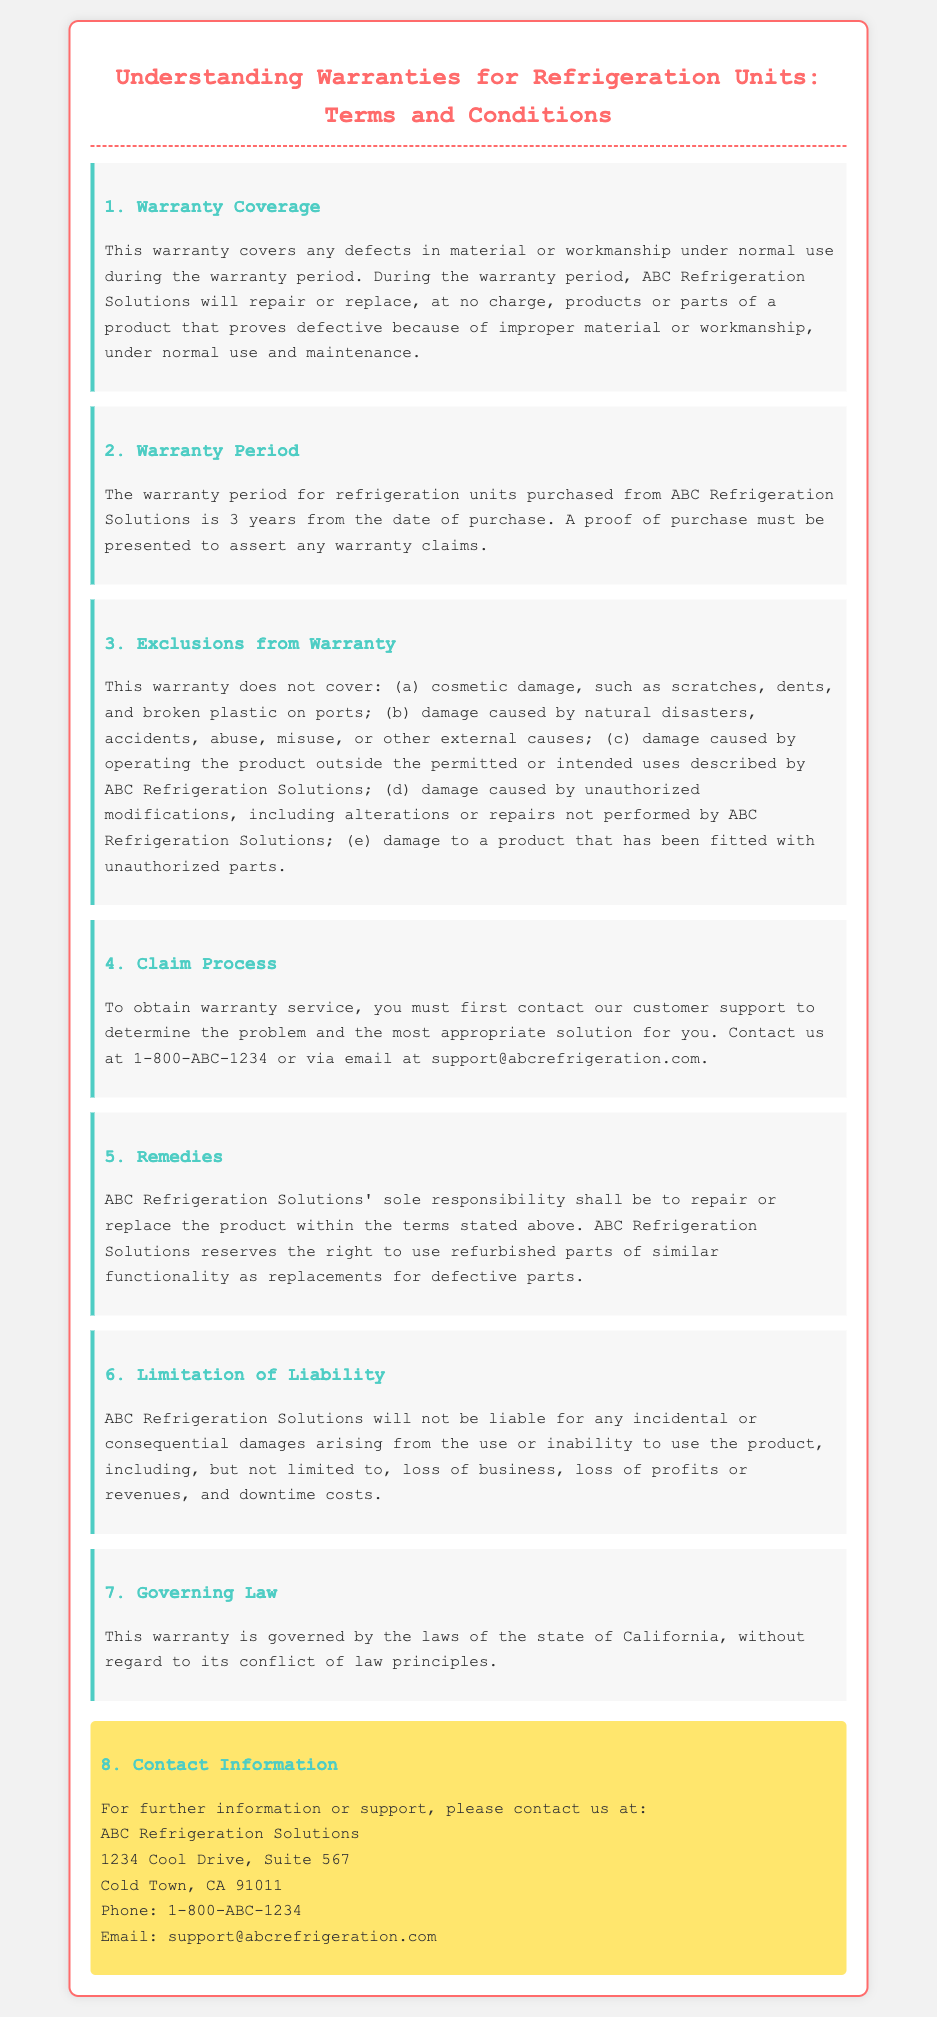What is the warranty period for refrigeration units? The warranty period for refrigeration units is explicitly stated to be 3 years from the date of purchase.
Answer: 3 years What must be presented to assert warranty claims? The document specifies that a proof of purchase must be presented to support any warranty claims.
Answer: Proof of purchase Which damages are excluded from the warranty? The warranty outlines specific exclusions including cosmetic damage, damage from natural disasters, and unauthorized modifications among others.
Answer: Cosmetic damage, natural disasters, unauthorized modifications What is the sole responsibility of ABC Refrigeration Solutions under this warranty? The document states that the sole responsibility is to repair or replace the product according to the warranty terms.
Answer: Repair or replace How can one contact customer support for warranty service? The document provides a direct phone number and an email address for contacting customer support regarding warranty service.
Answer: 1-800-ABC-1234 or support@abcrefrigeration.com Under which state's laws is this warranty governed? The warranty specifies that it is governed by the laws of the state of California.
Answer: California What type of parts may be used for replacements under the warranty? The document mentions that ABC Refrigeration Solutions reserves the right to use refurbished parts as replacements for defective parts.
Answer: Refurbished parts What types of damages is ABC Refrigeration Solutions not liable for? The warranty clearly states that ABC Refrigeration Solutions will not be liable for incidental or consequential damages arising from use or inability to use the product.
Answer: Incidental or consequential damages​ 